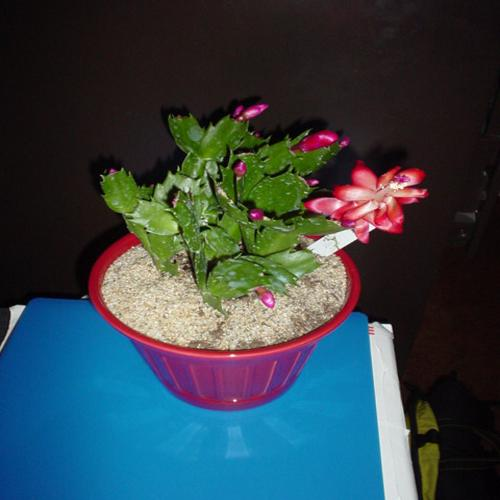Can you tell me more about the plant in this photo? Certainly! This plant is a Christmas cactus, known scientifically as Schlumbergera. Unlike typical desert cacti, this species originates from the Brazilian rainforest and is a popular houseplant due to its beautiful holiday blooms. The flowers range from white to pink to red, and the plant prefers a humid environment with bright, indirect light. 